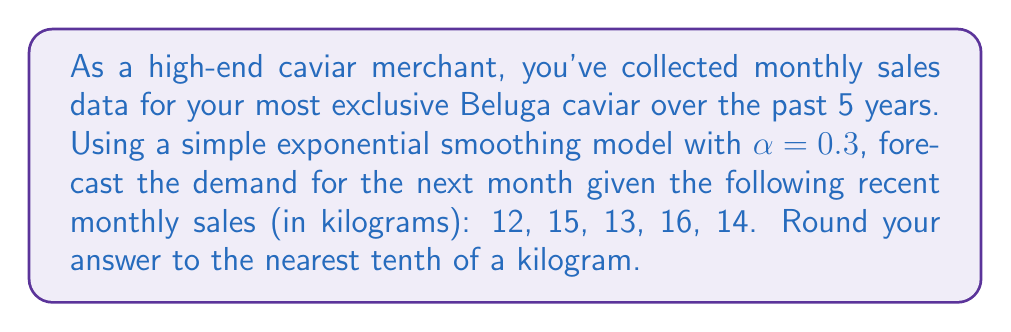Give your solution to this math problem. To solve this problem, we'll use the simple exponential smoothing model, which is a time series forecasting method. The formula for this model is:

$$F_{t+1} = αY_t + (1-α)F_t$$

Where:
$F_{t+1}$ is the forecast for the next period
$α$ is the smoothing constant (given as 0.3)
$Y_t$ is the actual observation in the current period
$F_t$ is the forecast for the current period

Let's apply this formula iteratively:

1) For the first period, we'll use the first observation as our initial forecast:
   $F_1 = 12$

2) For the second period:
   $F_2 = 0.3(12) + 0.7(12) = 12$

3) For the third period:
   $F_3 = 0.3(15) + 0.7(12) = 4.5 + 8.4 = 12.9$

4) For the fourth period:
   $F_4 = 0.3(13) + 0.7(12.9) = 3.9 + 9.03 = 12.93$

5) For the fifth period:
   $F_5 = 0.3(16) + 0.7(12.93) = 4.8 + 9.051 = 13.851$

6) For the sixth period (our forecast):
   $F_6 = 0.3(14) + 0.7(13.851) = 4.2 + 9.6957 = 13.8957$

Rounding to the nearest tenth, our forecast for the next month is 13.9 kg.
Answer: 13.9 kg 